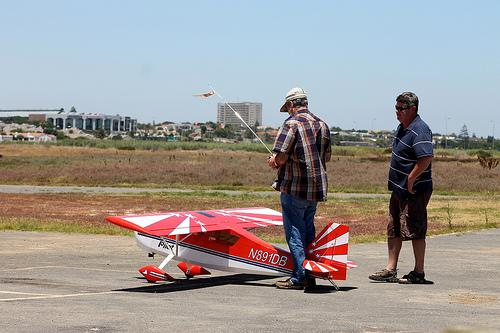Question: where was the picture taken?
Choices:
A. Train station.
B. Taxi stand.
C. Airport.
D. Bus stop.
Answer with the letter. Answer: C Question: who is holding the controls?
Choices:
A. Little boy.
B. Old woman.
C. Teenage boy.
D. Man with hat.
Answer with the letter. Answer: D Question: why are the men at the airport?
Choices:
A. To take a trip.
B. To navigate the plane.
C. Playing.
D. To load luggage.
Answer with the letter. Answer: C Question: what is on the man's head?
Choices:
A. Hat.
B. Helmet.
C. Bandana.
D. Sunglasses.
Answer with the letter. Answer: A 